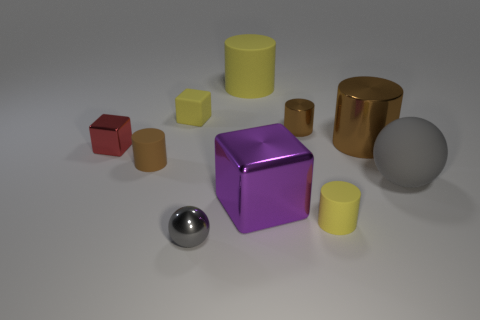Subtract all gray spheres. How many brown cylinders are left? 3 Subtract all big brown metallic cylinders. How many cylinders are left? 4 Subtract all red cylinders. Subtract all gray spheres. How many cylinders are left? 5 Subtract all spheres. How many objects are left? 8 Subtract all gray objects. Subtract all tiny shiny things. How many objects are left? 5 Add 7 gray metallic objects. How many gray metallic objects are left? 8 Add 1 small red shiny blocks. How many small red shiny blocks exist? 2 Subtract 0 cyan spheres. How many objects are left? 10 